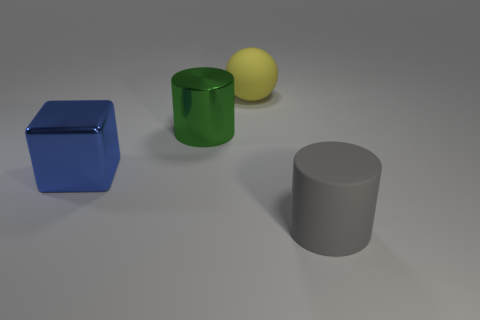Add 4 small yellow blocks. How many objects exist? 8 Subtract all cubes. How many objects are left? 3 Subtract 1 green cylinders. How many objects are left? 3 Subtract all yellow rubber cylinders. Subtract all big gray cylinders. How many objects are left? 3 Add 2 green objects. How many green objects are left? 3 Add 4 blocks. How many blocks exist? 5 